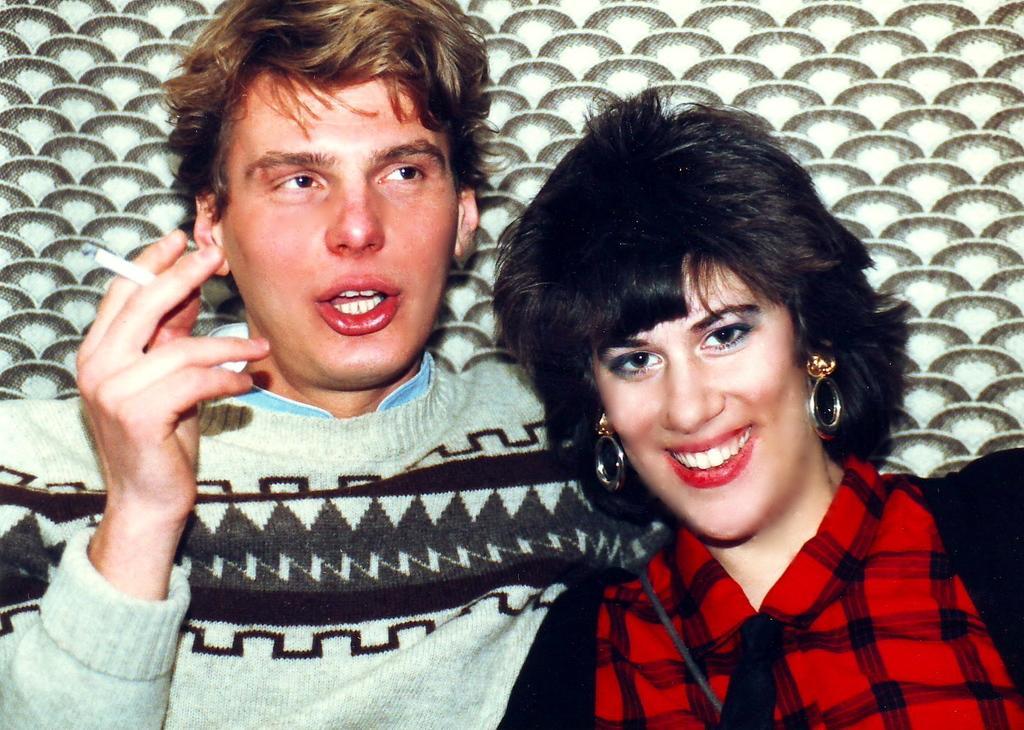Can you describe this image briefly? In this image I can see two people with black, red, green and blue color dresses. I can see there is a brown, cream and green background. 